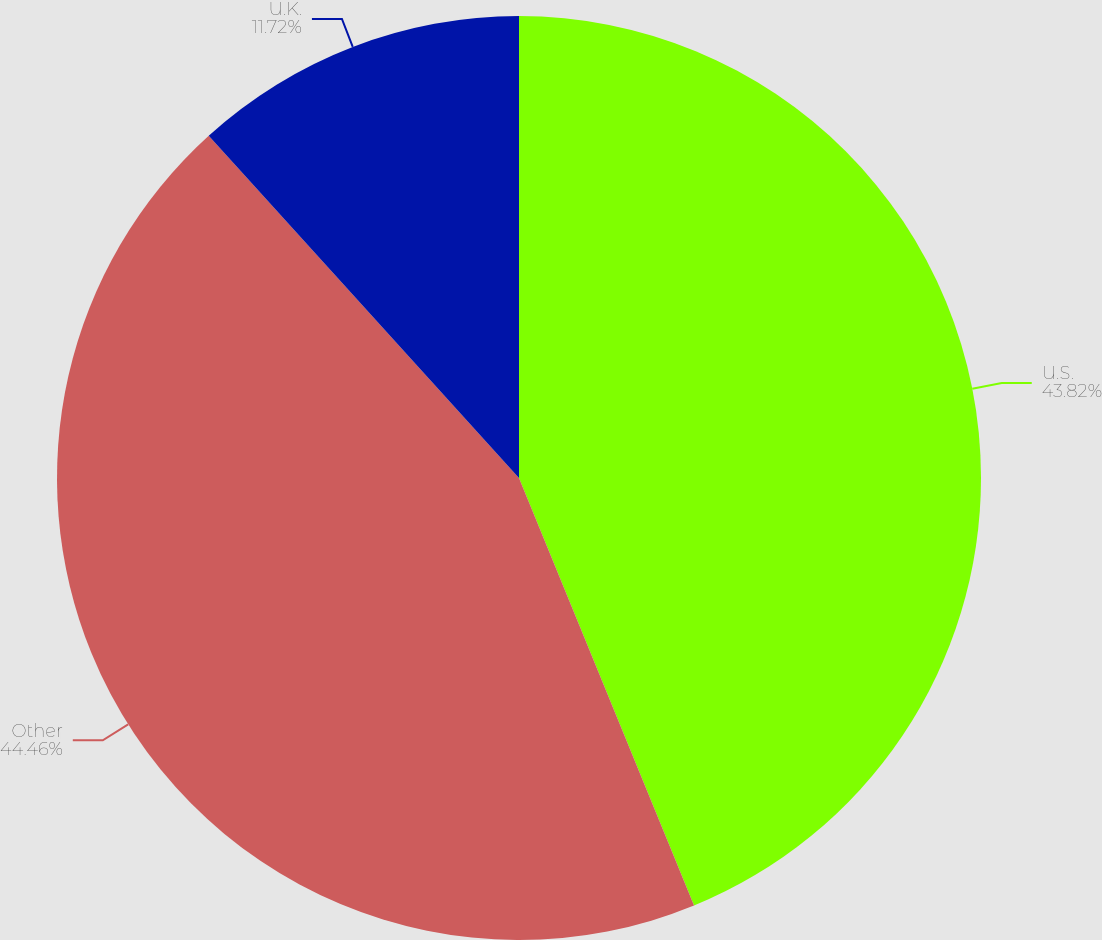Convert chart to OTSL. <chart><loc_0><loc_0><loc_500><loc_500><pie_chart><fcel>U.S.<fcel>Other<fcel>U.K.<nl><fcel>43.82%<fcel>44.47%<fcel>11.72%<nl></chart> 